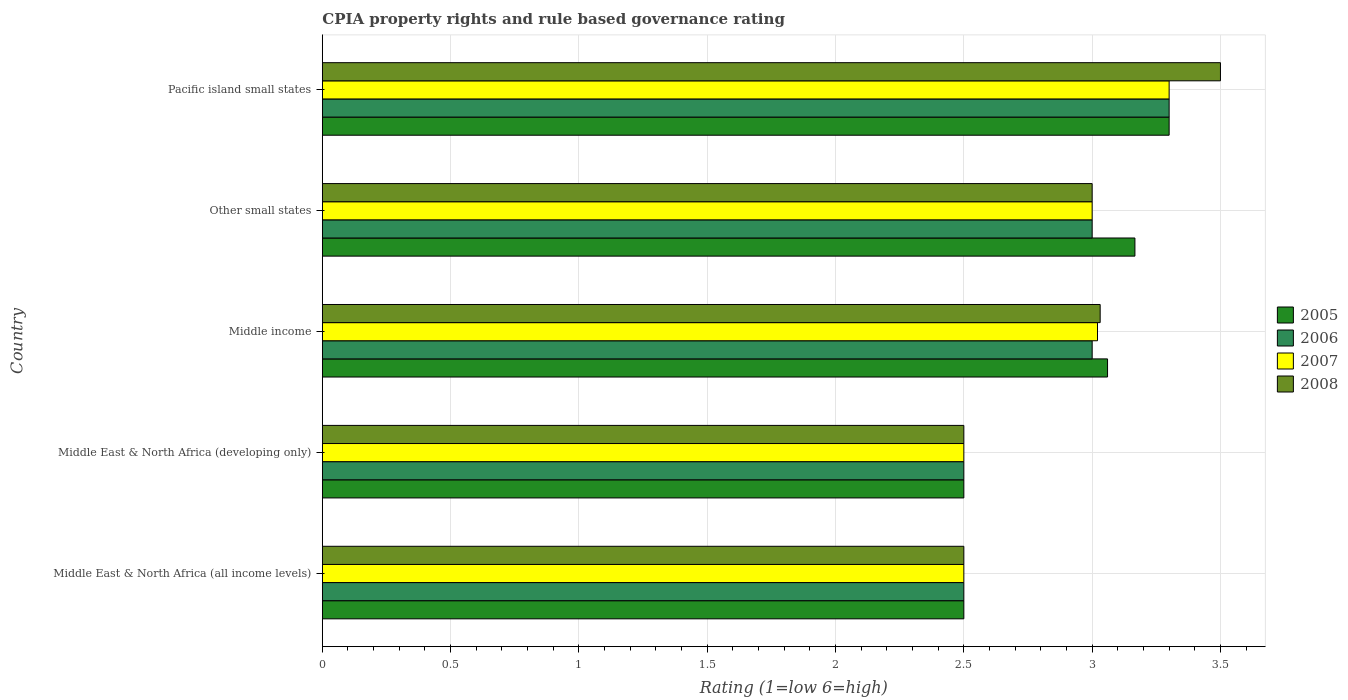How many groups of bars are there?
Provide a succinct answer. 5. Are the number of bars on each tick of the Y-axis equal?
Provide a succinct answer. Yes. What is the label of the 1st group of bars from the top?
Provide a short and direct response. Pacific island small states. What is the CPIA rating in 2006 in Middle East & North Africa (developing only)?
Provide a short and direct response. 2.5. Across all countries, what is the maximum CPIA rating in 2005?
Make the answer very short. 3.3. In which country was the CPIA rating in 2007 maximum?
Ensure brevity in your answer.  Pacific island small states. In which country was the CPIA rating in 2005 minimum?
Keep it short and to the point. Middle East & North Africa (all income levels). What is the total CPIA rating in 2007 in the graph?
Offer a terse response. 14.32. What is the difference between the CPIA rating in 2006 in Middle East & North Africa (developing only) and that in Pacific island small states?
Ensure brevity in your answer.  -0.8. What is the difference between the CPIA rating in 2007 in Middle income and the CPIA rating in 2006 in Middle East & North Africa (developing only)?
Your answer should be compact. 0.52. What is the average CPIA rating in 2006 per country?
Your answer should be very brief. 2.86. What is the difference between the CPIA rating in 2007 and CPIA rating in 2008 in Middle East & North Africa (all income levels)?
Your answer should be very brief. 0. What is the ratio of the CPIA rating in 2006 in Other small states to that in Pacific island small states?
Ensure brevity in your answer.  0.91. Is the CPIA rating in 2005 in Middle East & North Africa (all income levels) less than that in Other small states?
Provide a short and direct response. Yes. Is the difference between the CPIA rating in 2007 in Middle East & North Africa (all income levels) and Middle income greater than the difference between the CPIA rating in 2008 in Middle East & North Africa (all income levels) and Middle income?
Ensure brevity in your answer.  Yes. What is the difference between the highest and the second highest CPIA rating in 2005?
Your answer should be compact. 0.13. What is the difference between the highest and the lowest CPIA rating in 2007?
Keep it short and to the point. 0.8. Is the sum of the CPIA rating in 2006 in Middle income and Pacific island small states greater than the maximum CPIA rating in 2007 across all countries?
Make the answer very short. Yes. Is it the case that in every country, the sum of the CPIA rating in 2005 and CPIA rating in 2007 is greater than the sum of CPIA rating in 2006 and CPIA rating in 2008?
Keep it short and to the point. No. What does the 1st bar from the bottom in Middle East & North Africa (developing only) represents?
Provide a short and direct response. 2005. Are all the bars in the graph horizontal?
Offer a very short reply. Yes. How many countries are there in the graph?
Provide a succinct answer. 5. What is the difference between two consecutive major ticks on the X-axis?
Your answer should be compact. 0.5. Does the graph contain any zero values?
Provide a short and direct response. No. Where does the legend appear in the graph?
Provide a succinct answer. Center right. How are the legend labels stacked?
Give a very brief answer. Vertical. What is the title of the graph?
Offer a very short reply. CPIA property rights and rule based governance rating. Does "1986" appear as one of the legend labels in the graph?
Ensure brevity in your answer.  No. What is the label or title of the X-axis?
Provide a succinct answer. Rating (1=low 6=high). What is the label or title of the Y-axis?
Your answer should be very brief. Country. What is the Rating (1=low 6=high) in 2006 in Middle East & North Africa (all income levels)?
Provide a short and direct response. 2.5. What is the Rating (1=low 6=high) of 2007 in Middle East & North Africa (all income levels)?
Provide a succinct answer. 2.5. What is the Rating (1=low 6=high) of 2008 in Middle East & North Africa (all income levels)?
Ensure brevity in your answer.  2.5. What is the Rating (1=low 6=high) of 2005 in Middle East & North Africa (developing only)?
Give a very brief answer. 2.5. What is the Rating (1=low 6=high) of 2006 in Middle East & North Africa (developing only)?
Offer a very short reply. 2.5. What is the Rating (1=low 6=high) in 2007 in Middle East & North Africa (developing only)?
Make the answer very short. 2.5. What is the Rating (1=low 6=high) in 2008 in Middle East & North Africa (developing only)?
Your answer should be compact. 2.5. What is the Rating (1=low 6=high) in 2005 in Middle income?
Ensure brevity in your answer.  3.06. What is the Rating (1=low 6=high) of 2006 in Middle income?
Your response must be concise. 3. What is the Rating (1=low 6=high) in 2007 in Middle income?
Keep it short and to the point. 3.02. What is the Rating (1=low 6=high) of 2008 in Middle income?
Keep it short and to the point. 3.03. What is the Rating (1=low 6=high) in 2005 in Other small states?
Ensure brevity in your answer.  3.17. What is the Rating (1=low 6=high) in 2006 in Pacific island small states?
Your answer should be very brief. 3.3. What is the Rating (1=low 6=high) of 2007 in Pacific island small states?
Ensure brevity in your answer.  3.3. Across all countries, what is the maximum Rating (1=low 6=high) of 2005?
Make the answer very short. 3.3. Across all countries, what is the maximum Rating (1=low 6=high) of 2007?
Make the answer very short. 3.3. Across all countries, what is the maximum Rating (1=low 6=high) of 2008?
Ensure brevity in your answer.  3.5. Across all countries, what is the minimum Rating (1=low 6=high) in 2005?
Provide a short and direct response. 2.5. Across all countries, what is the minimum Rating (1=low 6=high) of 2006?
Ensure brevity in your answer.  2.5. Across all countries, what is the minimum Rating (1=low 6=high) of 2008?
Your answer should be compact. 2.5. What is the total Rating (1=low 6=high) in 2005 in the graph?
Keep it short and to the point. 14.53. What is the total Rating (1=low 6=high) of 2006 in the graph?
Keep it short and to the point. 14.3. What is the total Rating (1=low 6=high) in 2007 in the graph?
Give a very brief answer. 14.32. What is the total Rating (1=low 6=high) in 2008 in the graph?
Provide a short and direct response. 14.53. What is the difference between the Rating (1=low 6=high) of 2008 in Middle East & North Africa (all income levels) and that in Middle East & North Africa (developing only)?
Make the answer very short. 0. What is the difference between the Rating (1=low 6=high) in 2005 in Middle East & North Africa (all income levels) and that in Middle income?
Make the answer very short. -0.56. What is the difference between the Rating (1=low 6=high) in 2006 in Middle East & North Africa (all income levels) and that in Middle income?
Your response must be concise. -0.5. What is the difference between the Rating (1=low 6=high) of 2007 in Middle East & North Africa (all income levels) and that in Middle income?
Offer a terse response. -0.52. What is the difference between the Rating (1=low 6=high) in 2008 in Middle East & North Africa (all income levels) and that in Middle income?
Give a very brief answer. -0.53. What is the difference between the Rating (1=low 6=high) of 2006 in Middle East & North Africa (all income levels) and that in Other small states?
Make the answer very short. -0.5. What is the difference between the Rating (1=low 6=high) in 2007 in Middle East & North Africa (all income levels) and that in Pacific island small states?
Provide a short and direct response. -0.8. What is the difference between the Rating (1=low 6=high) in 2008 in Middle East & North Africa (all income levels) and that in Pacific island small states?
Keep it short and to the point. -1. What is the difference between the Rating (1=low 6=high) of 2005 in Middle East & North Africa (developing only) and that in Middle income?
Your response must be concise. -0.56. What is the difference between the Rating (1=low 6=high) of 2006 in Middle East & North Africa (developing only) and that in Middle income?
Provide a succinct answer. -0.5. What is the difference between the Rating (1=low 6=high) in 2007 in Middle East & North Africa (developing only) and that in Middle income?
Offer a terse response. -0.52. What is the difference between the Rating (1=low 6=high) of 2008 in Middle East & North Africa (developing only) and that in Middle income?
Make the answer very short. -0.53. What is the difference between the Rating (1=low 6=high) of 2005 in Middle East & North Africa (developing only) and that in Other small states?
Offer a terse response. -0.67. What is the difference between the Rating (1=low 6=high) of 2007 in Middle East & North Africa (developing only) and that in Other small states?
Offer a terse response. -0.5. What is the difference between the Rating (1=low 6=high) of 2008 in Middle East & North Africa (developing only) and that in Other small states?
Give a very brief answer. -0.5. What is the difference between the Rating (1=low 6=high) in 2008 in Middle East & North Africa (developing only) and that in Pacific island small states?
Your answer should be very brief. -1. What is the difference between the Rating (1=low 6=high) in 2005 in Middle income and that in Other small states?
Provide a short and direct response. -0.11. What is the difference between the Rating (1=low 6=high) in 2007 in Middle income and that in Other small states?
Ensure brevity in your answer.  0.02. What is the difference between the Rating (1=low 6=high) of 2008 in Middle income and that in Other small states?
Give a very brief answer. 0.03. What is the difference between the Rating (1=low 6=high) of 2005 in Middle income and that in Pacific island small states?
Offer a very short reply. -0.24. What is the difference between the Rating (1=low 6=high) in 2007 in Middle income and that in Pacific island small states?
Give a very brief answer. -0.28. What is the difference between the Rating (1=low 6=high) of 2008 in Middle income and that in Pacific island small states?
Give a very brief answer. -0.47. What is the difference between the Rating (1=low 6=high) of 2005 in Other small states and that in Pacific island small states?
Ensure brevity in your answer.  -0.13. What is the difference between the Rating (1=low 6=high) of 2006 in Other small states and that in Pacific island small states?
Your response must be concise. -0.3. What is the difference between the Rating (1=low 6=high) of 2005 in Middle East & North Africa (all income levels) and the Rating (1=low 6=high) of 2006 in Middle East & North Africa (developing only)?
Your answer should be very brief. 0. What is the difference between the Rating (1=low 6=high) of 2005 in Middle East & North Africa (all income levels) and the Rating (1=low 6=high) of 2008 in Middle East & North Africa (developing only)?
Your response must be concise. 0. What is the difference between the Rating (1=low 6=high) in 2007 in Middle East & North Africa (all income levels) and the Rating (1=low 6=high) in 2008 in Middle East & North Africa (developing only)?
Provide a succinct answer. 0. What is the difference between the Rating (1=low 6=high) of 2005 in Middle East & North Africa (all income levels) and the Rating (1=low 6=high) of 2006 in Middle income?
Your response must be concise. -0.5. What is the difference between the Rating (1=low 6=high) in 2005 in Middle East & North Africa (all income levels) and the Rating (1=low 6=high) in 2007 in Middle income?
Provide a succinct answer. -0.52. What is the difference between the Rating (1=low 6=high) of 2005 in Middle East & North Africa (all income levels) and the Rating (1=low 6=high) of 2008 in Middle income?
Keep it short and to the point. -0.53. What is the difference between the Rating (1=low 6=high) in 2006 in Middle East & North Africa (all income levels) and the Rating (1=low 6=high) in 2007 in Middle income?
Offer a terse response. -0.52. What is the difference between the Rating (1=low 6=high) of 2006 in Middle East & North Africa (all income levels) and the Rating (1=low 6=high) of 2008 in Middle income?
Keep it short and to the point. -0.53. What is the difference between the Rating (1=low 6=high) in 2007 in Middle East & North Africa (all income levels) and the Rating (1=low 6=high) in 2008 in Middle income?
Give a very brief answer. -0.53. What is the difference between the Rating (1=low 6=high) in 2005 in Middle East & North Africa (all income levels) and the Rating (1=low 6=high) in 2006 in Other small states?
Provide a succinct answer. -0.5. What is the difference between the Rating (1=low 6=high) of 2005 in Middle East & North Africa (all income levels) and the Rating (1=low 6=high) of 2008 in Other small states?
Offer a very short reply. -0.5. What is the difference between the Rating (1=low 6=high) of 2006 in Middle East & North Africa (all income levels) and the Rating (1=low 6=high) of 2007 in Other small states?
Your answer should be compact. -0.5. What is the difference between the Rating (1=low 6=high) of 2006 in Middle East & North Africa (all income levels) and the Rating (1=low 6=high) of 2008 in Other small states?
Make the answer very short. -0.5. What is the difference between the Rating (1=low 6=high) in 2007 in Middle East & North Africa (all income levels) and the Rating (1=low 6=high) in 2008 in Other small states?
Give a very brief answer. -0.5. What is the difference between the Rating (1=low 6=high) of 2006 in Middle East & North Africa (all income levels) and the Rating (1=low 6=high) of 2007 in Pacific island small states?
Offer a terse response. -0.8. What is the difference between the Rating (1=low 6=high) of 2007 in Middle East & North Africa (all income levels) and the Rating (1=low 6=high) of 2008 in Pacific island small states?
Provide a succinct answer. -1. What is the difference between the Rating (1=low 6=high) of 2005 in Middle East & North Africa (developing only) and the Rating (1=low 6=high) of 2006 in Middle income?
Offer a very short reply. -0.5. What is the difference between the Rating (1=low 6=high) in 2005 in Middle East & North Africa (developing only) and the Rating (1=low 6=high) in 2007 in Middle income?
Your response must be concise. -0.52. What is the difference between the Rating (1=low 6=high) of 2005 in Middle East & North Africa (developing only) and the Rating (1=low 6=high) of 2008 in Middle income?
Offer a very short reply. -0.53. What is the difference between the Rating (1=low 6=high) in 2006 in Middle East & North Africa (developing only) and the Rating (1=low 6=high) in 2007 in Middle income?
Your answer should be very brief. -0.52. What is the difference between the Rating (1=low 6=high) of 2006 in Middle East & North Africa (developing only) and the Rating (1=low 6=high) of 2008 in Middle income?
Your answer should be compact. -0.53. What is the difference between the Rating (1=low 6=high) in 2007 in Middle East & North Africa (developing only) and the Rating (1=low 6=high) in 2008 in Middle income?
Your answer should be very brief. -0.53. What is the difference between the Rating (1=low 6=high) of 2005 in Middle East & North Africa (developing only) and the Rating (1=low 6=high) of 2006 in Other small states?
Your response must be concise. -0.5. What is the difference between the Rating (1=low 6=high) in 2005 in Middle East & North Africa (developing only) and the Rating (1=low 6=high) in 2007 in Other small states?
Provide a succinct answer. -0.5. What is the difference between the Rating (1=low 6=high) in 2005 in Middle East & North Africa (developing only) and the Rating (1=low 6=high) in 2008 in Other small states?
Give a very brief answer. -0.5. What is the difference between the Rating (1=low 6=high) of 2006 in Middle East & North Africa (developing only) and the Rating (1=low 6=high) of 2008 in Other small states?
Offer a terse response. -0.5. What is the difference between the Rating (1=low 6=high) of 2006 in Middle East & North Africa (developing only) and the Rating (1=low 6=high) of 2007 in Pacific island small states?
Give a very brief answer. -0.8. What is the difference between the Rating (1=low 6=high) of 2007 in Middle East & North Africa (developing only) and the Rating (1=low 6=high) of 2008 in Pacific island small states?
Ensure brevity in your answer.  -1. What is the difference between the Rating (1=low 6=high) in 2005 in Middle income and the Rating (1=low 6=high) in 2006 in Other small states?
Your response must be concise. 0.06. What is the difference between the Rating (1=low 6=high) in 2005 in Middle income and the Rating (1=low 6=high) in 2007 in Other small states?
Offer a terse response. 0.06. What is the difference between the Rating (1=low 6=high) in 2005 in Middle income and the Rating (1=low 6=high) in 2008 in Other small states?
Ensure brevity in your answer.  0.06. What is the difference between the Rating (1=low 6=high) in 2006 in Middle income and the Rating (1=low 6=high) in 2008 in Other small states?
Offer a terse response. 0. What is the difference between the Rating (1=low 6=high) of 2007 in Middle income and the Rating (1=low 6=high) of 2008 in Other small states?
Make the answer very short. 0.02. What is the difference between the Rating (1=low 6=high) in 2005 in Middle income and the Rating (1=low 6=high) in 2006 in Pacific island small states?
Offer a very short reply. -0.24. What is the difference between the Rating (1=low 6=high) in 2005 in Middle income and the Rating (1=low 6=high) in 2007 in Pacific island small states?
Provide a short and direct response. -0.24. What is the difference between the Rating (1=low 6=high) of 2005 in Middle income and the Rating (1=low 6=high) of 2008 in Pacific island small states?
Give a very brief answer. -0.44. What is the difference between the Rating (1=low 6=high) in 2006 in Middle income and the Rating (1=low 6=high) in 2007 in Pacific island small states?
Offer a very short reply. -0.3. What is the difference between the Rating (1=low 6=high) in 2006 in Middle income and the Rating (1=low 6=high) in 2008 in Pacific island small states?
Ensure brevity in your answer.  -0.5. What is the difference between the Rating (1=low 6=high) in 2007 in Middle income and the Rating (1=low 6=high) in 2008 in Pacific island small states?
Provide a succinct answer. -0.48. What is the difference between the Rating (1=low 6=high) of 2005 in Other small states and the Rating (1=low 6=high) of 2006 in Pacific island small states?
Your response must be concise. -0.13. What is the difference between the Rating (1=low 6=high) of 2005 in Other small states and the Rating (1=low 6=high) of 2007 in Pacific island small states?
Keep it short and to the point. -0.13. What is the difference between the Rating (1=low 6=high) in 2006 in Other small states and the Rating (1=low 6=high) in 2008 in Pacific island small states?
Your answer should be very brief. -0.5. What is the average Rating (1=low 6=high) of 2005 per country?
Your response must be concise. 2.91. What is the average Rating (1=low 6=high) of 2006 per country?
Provide a succinct answer. 2.86. What is the average Rating (1=low 6=high) of 2007 per country?
Keep it short and to the point. 2.86. What is the average Rating (1=low 6=high) in 2008 per country?
Your answer should be compact. 2.91. What is the difference between the Rating (1=low 6=high) of 2006 and Rating (1=low 6=high) of 2007 in Middle East & North Africa (all income levels)?
Your answer should be very brief. 0. What is the difference between the Rating (1=low 6=high) of 2006 and Rating (1=low 6=high) of 2008 in Middle East & North Africa (all income levels)?
Keep it short and to the point. 0. What is the difference between the Rating (1=low 6=high) in 2005 and Rating (1=low 6=high) in 2007 in Middle East & North Africa (developing only)?
Your answer should be compact. 0. What is the difference between the Rating (1=low 6=high) in 2005 and Rating (1=low 6=high) in 2008 in Middle East & North Africa (developing only)?
Ensure brevity in your answer.  0. What is the difference between the Rating (1=low 6=high) of 2006 and Rating (1=low 6=high) of 2007 in Middle East & North Africa (developing only)?
Your answer should be very brief. 0. What is the difference between the Rating (1=low 6=high) of 2006 and Rating (1=low 6=high) of 2008 in Middle East & North Africa (developing only)?
Keep it short and to the point. 0. What is the difference between the Rating (1=low 6=high) in 2005 and Rating (1=low 6=high) in 2006 in Middle income?
Offer a terse response. 0.06. What is the difference between the Rating (1=low 6=high) in 2005 and Rating (1=low 6=high) in 2007 in Middle income?
Provide a short and direct response. 0.04. What is the difference between the Rating (1=low 6=high) of 2005 and Rating (1=low 6=high) of 2008 in Middle income?
Make the answer very short. 0.03. What is the difference between the Rating (1=low 6=high) in 2006 and Rating (1=low 6=high) in 2007 in Middle income?
Make the answer very short. -0.02. What is the difference between the Rating (1=low 6=high) of 2006 and Rating (1=low 6=high) of 2008 in Middle income?
Give a very brief answer. -0.03. What is the difference between the Rating (1=low 6=high) of 2007 and Rating (1=low 6=high) of 2008 in Middle income?
Provide a succinct answer. -0.01. What is the difference between the Rating (1=low 6=high) of 2005 and Rating (1=low 6=high) of 2008 in Other small states?
Your response must be concise. 0.17. What is the difference between the Rating (1=low 6=high) in 2006 and Rating (1=low 6=high) in 2007 in Other small states?
Offer a terse response. 0. What is the difference between the Rating (1=low 6=high) of 2006 and Rating (1=low 6=high) of 2008 in Other small states?
Offer a very short reply. 0. What is the difference between the Rating (1=low 6=high) in 2007 and Rating (1=low 6=high) in 2008 in Other small states?
Give a very brief answer. 0. What is the difference between the Rating (1=low 6=high) of 2005 and Rating (1=low 6=high) of 2007 in Pacific island small states?
Offer a terse response. 0. What is the difference between the Rating (1=low 6=high) of 2005 and Rating (1=low 6=high) of 2008 in Pacific island small states?
Give a very brief answer. -0.2. What is the difference between the Rating (1=low 6=high) of 2006 and Rating (1=low 6=high) of 2008 in Pacific island small states?
Your answer should be compact. -0.2. What is the ratio of the Rating (1=low 6=high) of 2005 in Middle East & North Africa (all income levels) to that in Middle East & North Africa (developing only)?
Keep it short and to the point. 1. What is the ratio of the Rating (1=low 6=high) of 2006 in Middle East & North Africa (all income levels) to that in Middle East & North Africa (developing only)?
Your answer should be very brief. 1. What is the ratio of the Rating (1=low 6=high) in 2007 in Middle East & North Africa (all income levels) to that in Middle East & North Africa (developing only)?
Offer a terse response. 1. What is the ratio of the Rating (1=low 6=high) of 2005 in Middle East & North Africa (all income levels) to that in Middle income?
Offer a terse response. 0.82. What is the ratio of the Rating (1=low 6=high) in 2007 in Middle East & North Africa (all income levels) to that in Middle income?
Your answer should be very brief. 0.83. What is the ratio of the Rating (1=low 6=high) of 2008 in Middle East & North Africa (all income levels) to that in Middle income?
Your response must be concise. 0.82. What is the ratio of the Rating (1=low 6=high) in 2005 in Middle East & North Africa (all income levels) to that in Other small states?
Provide a succinct answer. 0.79. What is the ratio of the Rating (1=low 6=high) in 2005 in Middle East & North Africa (all income levels) to that in Pacific island small states?
Offer a very short reply. 0.76. What is the ratio of the Rating (1=low 6=high) in 2006 in Middle East & North Africa (all income levels) to that in Pacific island small states?
Your response must be concise. 0.76. What is the ratio of the Rating (1=low 6=high) in 2007 in Middle East & North Africa (all income levels) to that in Pacific island small states?
Give a very brief answer. 0.76. What is the ratio of the Rating (1=low 6=high) of 2005 in Middle East & North Africa (developing only) to that in Middle income?
Your answer should be very brief. 0.82. What is the ratio of the Rating (1=low 6=high) of 2006 in Middle East & North Africa (developing only) to that in Middle income?
Give a very brief answer. 0.83. What is the ratio of the Rating (1=low 6=high) of 2007 in Middle East & North Africa (developing only) to that in Middle income?
Offer a terse response. 0.83. What is the ratio of the Rating (1=low 6=high) in 2008 in Middle East & North Africa (developing only) to that in Middle income?
Keep it short and to the point. 0.82. What is the ratio of the Rating (1=low 6=high) in 2005 in Middle East & North Africa (developing only) to that in Other small states?
Offer a terse response. 0.79. What is the ratio of the Rating (1=low 6=high) of 2006 in Middle East & North Africa (developing only) to that in Other small states?
Give a very brief answer. 0.83. What is the ratio of the Rating (1=low 6=high) in 2008 in Middle East & North Africa (developing only) to that in Other small states?
Offer a terse response. 0.83. What is the ratio of the Rating (1=low 6=high) in 2005 in Middle East & North Africa (developing only) to that in Pacific island small states?
Your answer should be very brief. 0.76. What is the ratio of the Rating (1=low 6=high) of 2006 in Middle East & North Africa (developing only) to that in Pacific island small states?
Ensure brevity in your answer.  0.76. What is the ratio of the Rating (1=low 6=high) of 2007 in Middle East & North Africa (developing only) to that in Pacific island small states?
Offer a very short reply. 0.76. What is the ratio of the Rating (1=low 6=high) in 2005 in Middle income to that in Other small states?
Keep it short and to the point. 0.97. What is the ratio of the Rating (1=low 6=high) of 2007 in Middle income to that in Other small states?
Give a very brief answer. 1.01. What is the ratio of the Rating (1=low 6=high) in 2008 in Middle income to that in Other small states?
Provide a succinct answer. 1.01. What is the ratio of the Rating (1=low 6=high) in 2005 in Middle income to that in Pacific island small states?
Give a very brief answer. 0.93. What is the ratio of the Rating (1=low 6=high) in 2006 in Middle income to that in Pacific island small states?
Offer a very short reply. 0.91. What is the ratio of the Rating (1=low 6=high) in 2007 in Middle income to that in Pacific island small states?
Provide a succinct answer. 0.92. What is the ratio of the Rating (1=low 6=high) in 2008 in Middle income to that in Pacific island small states?
Provide a short and direct response. 0.87. What is the ratio of the Rating (1=low 6=high) of 2005 in Other small states to that in Pacific island small states?
Make the answer very short. 0.96. What is the ratio of the Rating (1=low 6=high) in 2006 in Other small states to that in Pacific island small states?
Provide a short and direct response. 0.91. What is the ratio of the Rating (1=low 6=high) of 2007 in Other small states to that in Pacific island small states?
Offer a terse response. 0.91. What is the ratio of the Rating (1=low 6=high) of 2008 in Other small states to that in Pacific island small states?
Your answer should be very brief. 0.86. What is the difference between the highest and the second highest Rating (1=low 6=high) of 2005?
Ensure brevity in your answer.  0.13. What is the difference between the highest and the second highest Rating (1=low 6=high) in 2006?
Make the answer very short. 0.3. What is the difference between the highest and the second highest Rating (1=low 6=high) of 2007?
Give a very brief answer. 0.28. What is the difference between the highest and the second highest Rating (1=low 6=high) in 2008?
Provide a succinct answer. 0.47. 